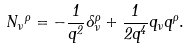Convert formula to latex. <formula><loc_0><loc_0><loc_500><loc_500>N _ { \nu } { ^ { \rho } } = - \frac { 1 } { q ^ { 2 } } \delta ^ { \rho } _ { \nu } + \frac { 1 } { 2 q ^ { 4 } } q _ { \nu } q ^ { \rho } .</formula> 